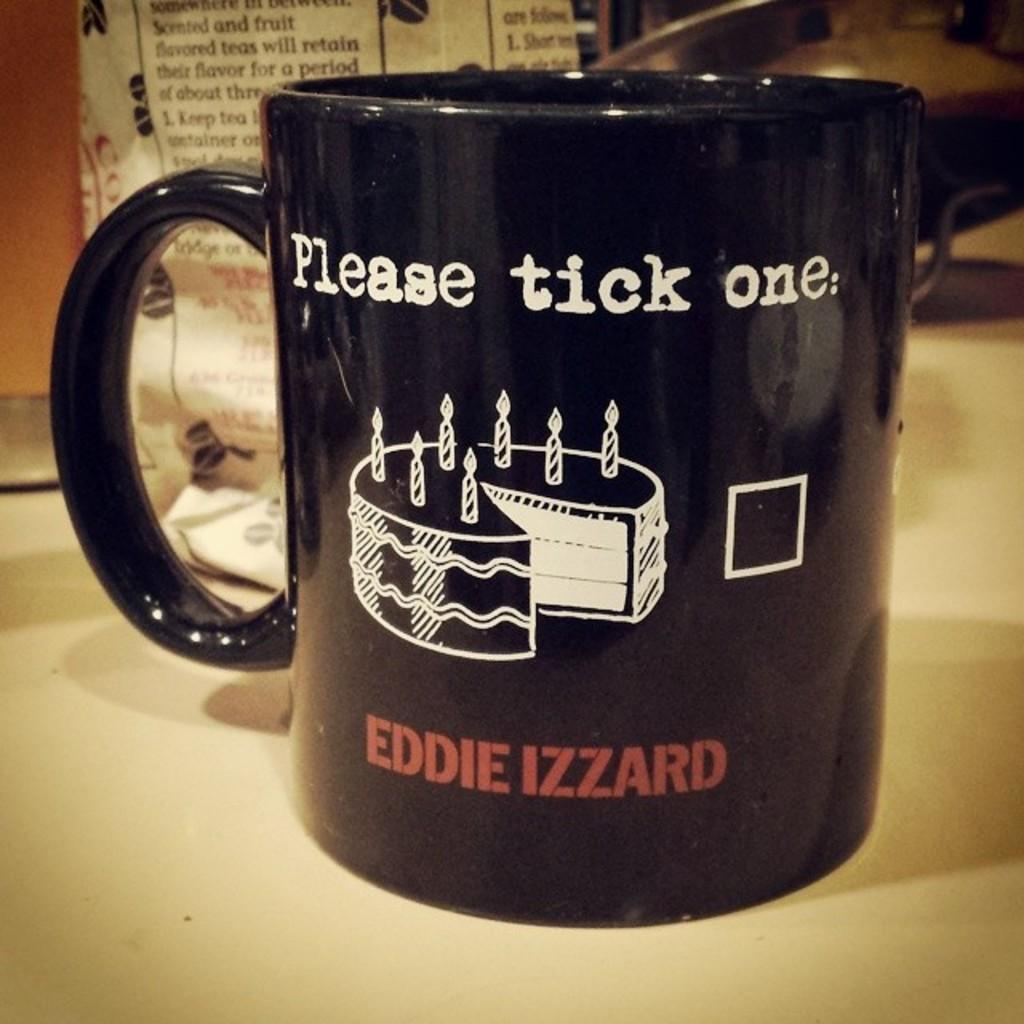<image>
Create a compact narrative representing the image presented. A black mug on a counter that says Please tick one. 